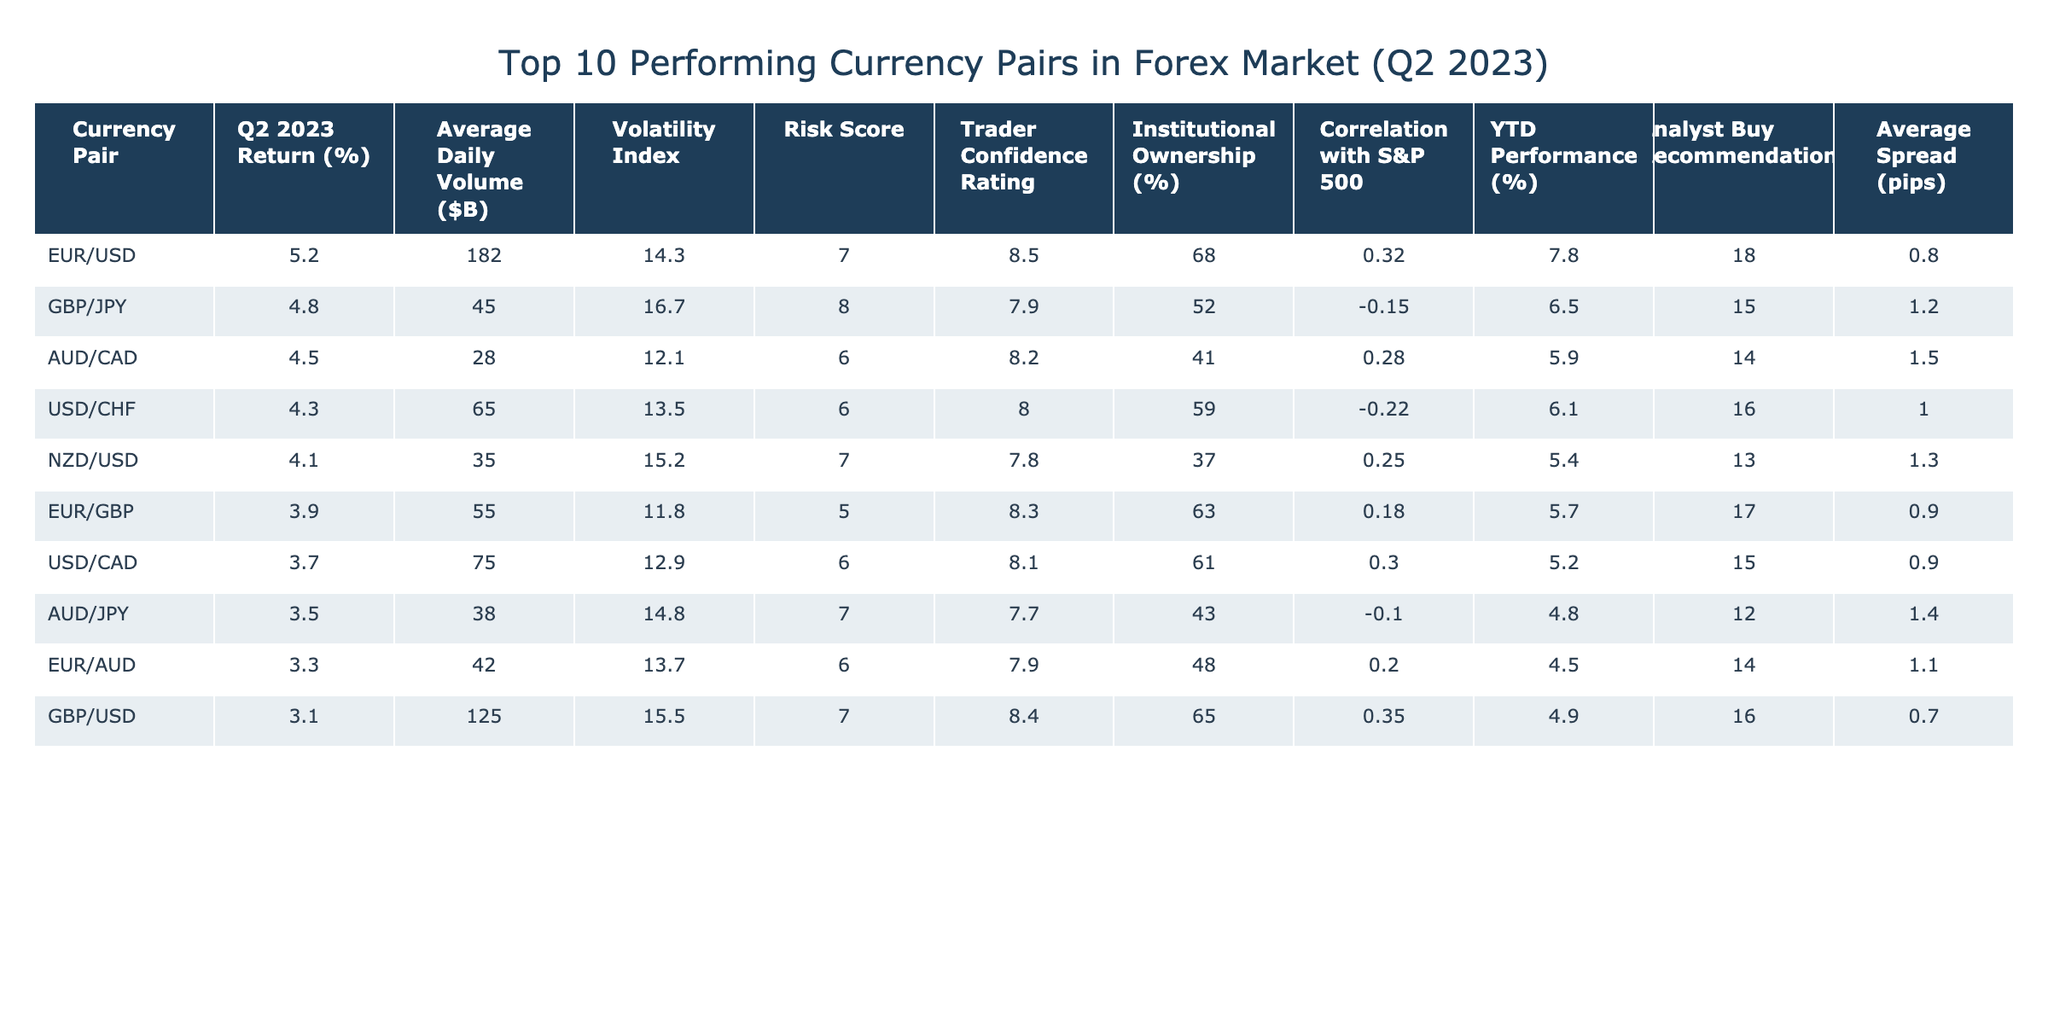What is the highest return percentage among the currency pairs in Q2 2023? The table shows the return percentages for each currency pair. The highest return percentage is listed next to the EUR/USD pair, which shows 5.2%.
Answer: 5.2% Which currency pair has the lowest average daily volume? The average daily volumes are presented in the table, and the lowest is listed next to the AUD/CAD pair with 28 billion dollars.
Answer: 28 What is the difference in return percentage between the EUR/USD and GBP/JPY pairs? The return for EUR/USD is 5.2% and for GBP/JPY is 4.8%. Calculating the difference: 5.2% - 4.8% = 0.4%.
Answer: 0.4% How many currency pairs have an institutional ownership percentage greater than 60%? The institutional ownership percentages are given for each pair. Those over 60% are EUR/USD (68%), USD/CHF (59%), and GBP/USD (65%). Only two meet the criterion: EUR/USD and GBP/USD.
Answer: 2 Which currency pair has the highest volatility index and what is it? From the table, GBP/JPY has the highest volatility index at 16.7, compared to the others.
Answer: GBP/JPY, 16.7 Are there any currency pairs with a correlation to the S&P 500 that is negative? Negative correlation values are visible in the table; pairs with negative correlation are GBP/JPY (-0.15) and USD/CHF (-0.22). Therefore, yes, there are two pairs.
Answer: Yes If I were to average the returns of the top three performing currency pairs, what would it be? The top three performing currency pairs are EUR/USD (5.2%), GBP/JPY (4.8%), and AUD/CAD (4.5%). The average is calculated as (5.2 + 4.8 + 4.5) / 3 = 4.83%.
Answer: 4.83% What is the correlation of the AUD/CAD pair with the S&P 500? The table lists the correlation for AUD/CAD as 0.28, showing a positive correlation with the S&P 500.
Answer: 0.28 Which currency pair has the highest trader confidence rating? Reviewing the trader confidence ratings, EUR/USD has the highest at 8.5, greater than the rest.
Answer: EUR/USD, 8.5 Is the average spread for GBP/USD greater than that for EUR/USD? Checking the average spreads: GBP/USD is 0.7 pips while EUR/USD is 0.8 pips. Since 0.7 is less than 0.8, the statement is false.
Answer: No 